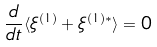<formula> <loc_0><loc_0><loc_500><loc_500>\frac { d } { d t } \langle \xi ^ { ( 1 ) } + \xi ^ { ( 1 ) * } \rangle = 0</formula> 